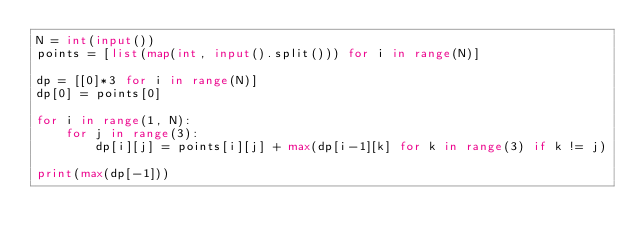Convert code to text. <code><loc_0><loc_0><loc_500><loc_500><_Python_>N = int(input())
points = [list(map(int, input().split())) for i in range(N)]

dp = [[0]*3 for i in range(N)]
dp[0] = points[0]

for i in range(1, N):
    for j in range(3):
        dp[i][j] = points[i][j] + max(dp[i-1][k] for k in range(3) if k != j)

print(max(dp[-1]))
</code> 